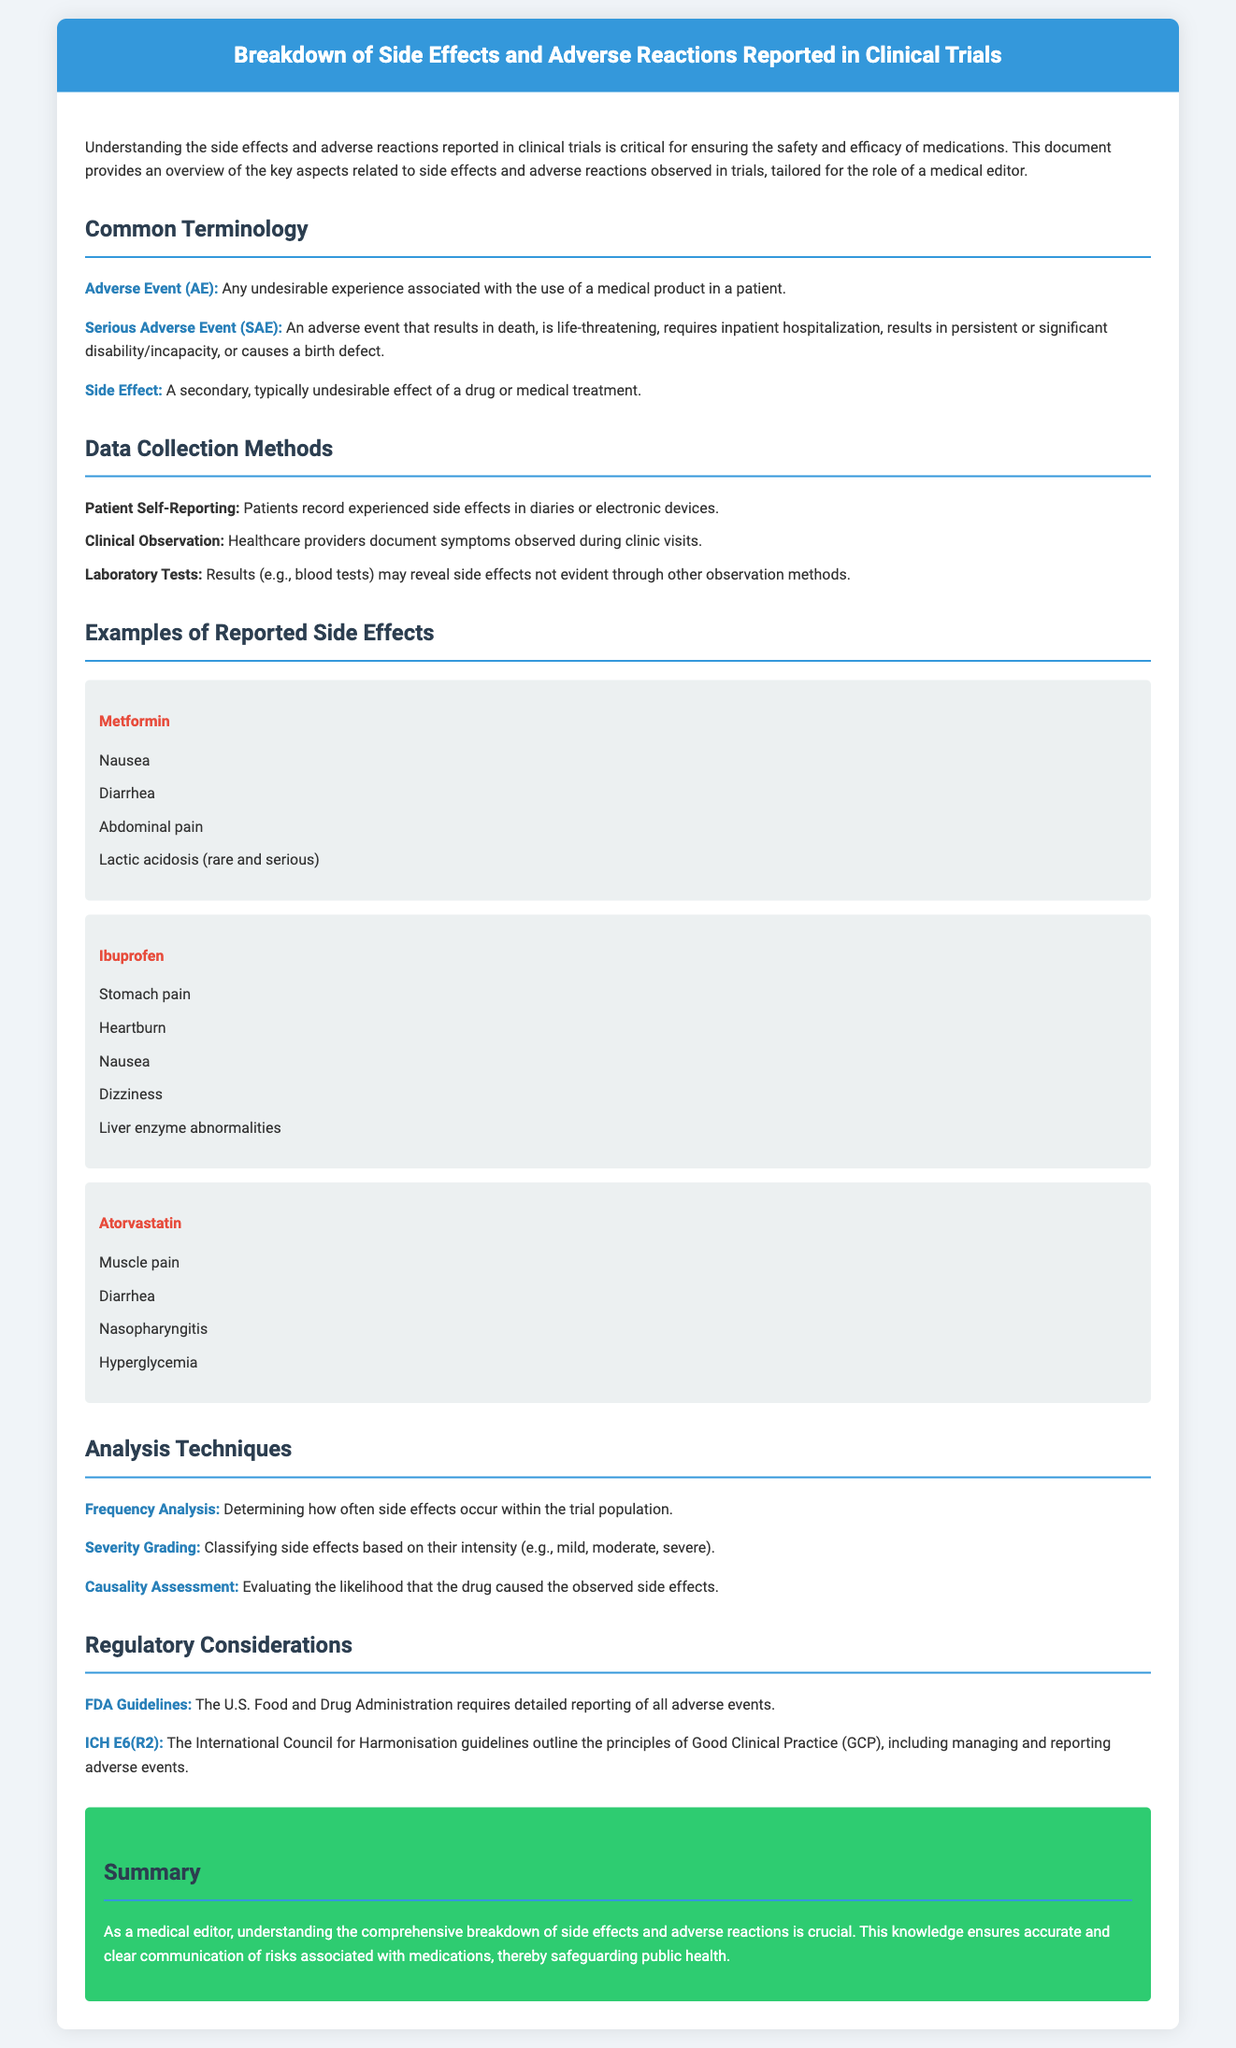What is an Adverse Event (AE)? An Adverse Event (AE) is defined in the document as any undesirable experience associated with the use of a medical product in a patient.
Answer: Any undesirable experience What side effect is associated with Metformin? The document lists nausea, diarrhea, abdominal pain, and lactic acidosis as side effects associated with Metformin.
Answer: Nausea What is the purpose of frequency analysis in clinical trials? Frequency analysis is mentioned as a technique for determining how often side effects occur within the trial population.
Answer: How often side effects occur Name one regulatory guideline mentioned in the document. The document references the FDA Guidelines as a regulatory consideration for adverse event reporting.
Answer: FDA Guidelines What is a Serious Adverse Event (SAE)? A Serious Adverse Event (SAE) is described as an adverse event that results in death or is life-threatening, among other criteria.
Answer: Life-threatening How does the document classify side effects based on severity? It states that severity grading classifies side effects based on their intensity, including categories such as mild, moderate, and severe.
Answer: Mild, moderate, severe What is one method of data collection mentioned? The document lists patient self-reporting as one method of collecting data on side effects.
Answer: Patient self-reporting What is the primary role of a medical editor as described in the summary? The summary emphasizes that a medical editor's role involves understanding the breakdown of side effects and adverse reactions for accurate communication of medication risks.
Answer: Accurate communication of medication risks 